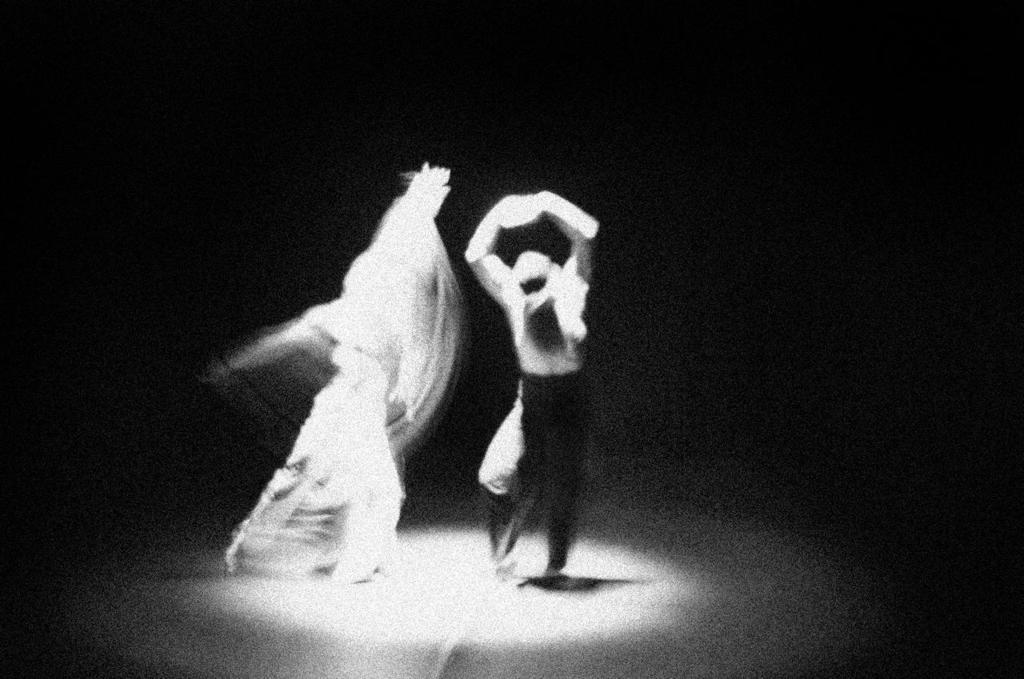Could you give a brief overview of what you see in this image? In this image we can see two persons are dancing, and the picture is blurred. 